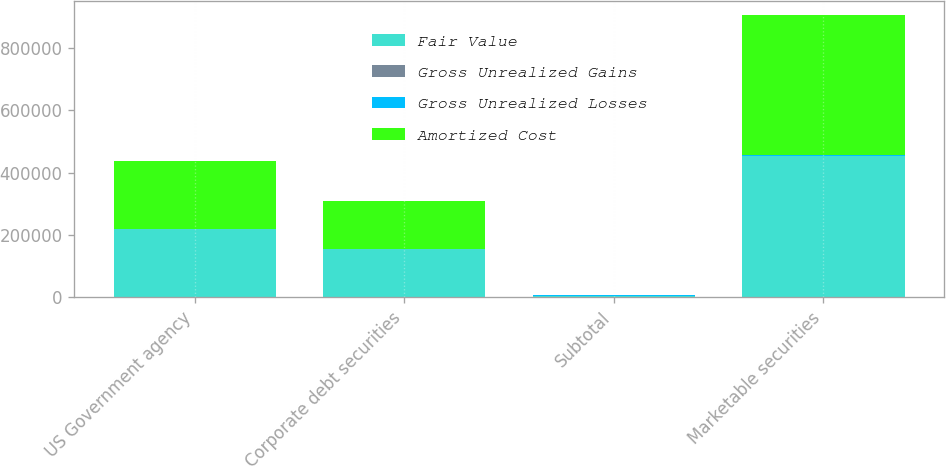Convert chart. <chart><loc_0><loc_0><loc_500><loc_500><stacked_bar_chart><ecel><fcel>US Government agency<fcel>Corporate debt securities<fcel>Subtotal<fcel>Marketable securities<nl><fcel>Fair Value<fcel>217881<fcel>154353<fcel>2354<fcel>453370<nl><fcel>Gross Unrealized Gains<fcel>193<fcel>15<fcel>261<fcel>261<nl><fcel>Gross Unrealized Losses<fcel>199<fcel>793<fcel>2354<fcel>2354<nl><fcel>Amortized Cost<fcel>217875<fcel>153575<fcel>2354<fcel>451277<nl></chart> 